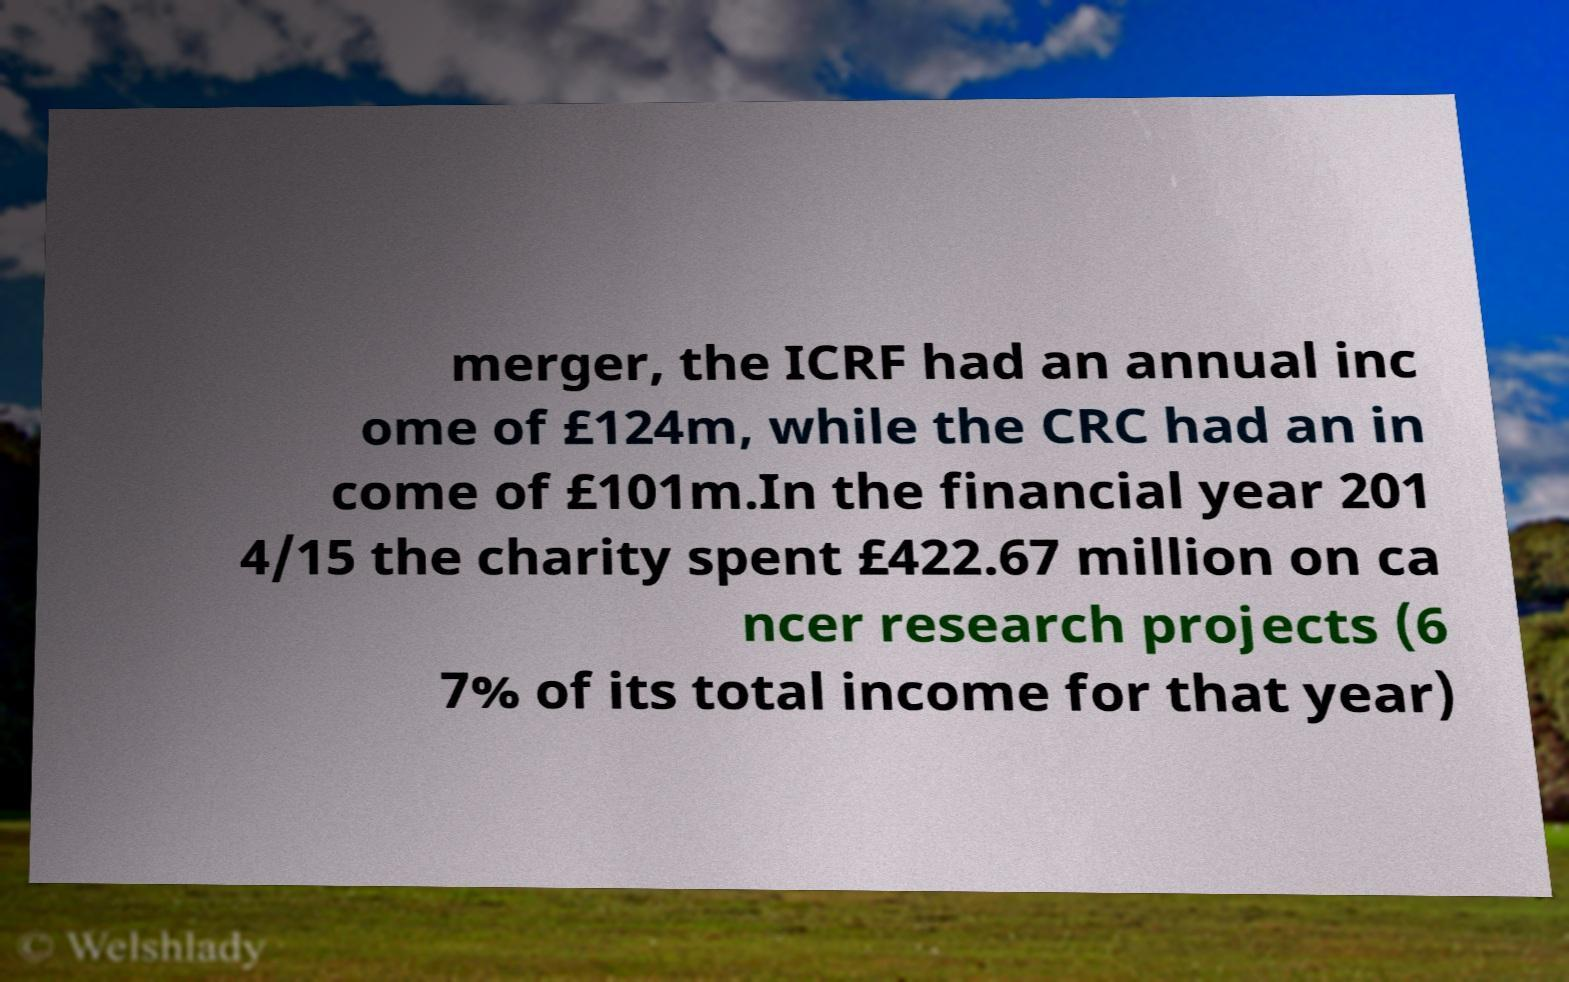For documentation purposes, I need the text within this image transcribed. Could you provide that? merger, the ICRF had an annual inc ome of £124m, while the CRC had an in come of £101m.In the financial year 201 4/15 the charity spent £422.67 million on ca ncer research projects (6 7% of its total income for that year) 